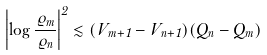<formula> <loc_0><loc_0><loc_500><loc_500>\left | \log \frac { \varrho _ { m } } { \varrho _ { n } } \right | ^ { 2 } \lesssim ( V _ { m + 1 } - V _ { n + 1 } ) ( Q _ { n } - Q _ { m } )</formula> 